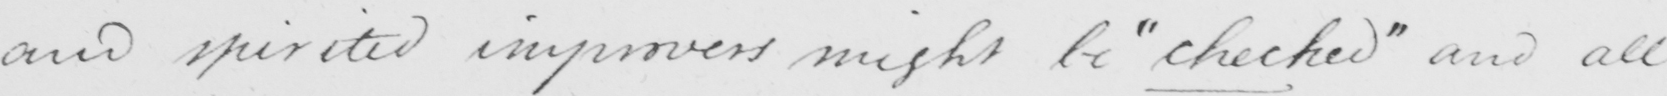What is written in this line of handwriting? and spirited improvers might be  " checked "  and all 